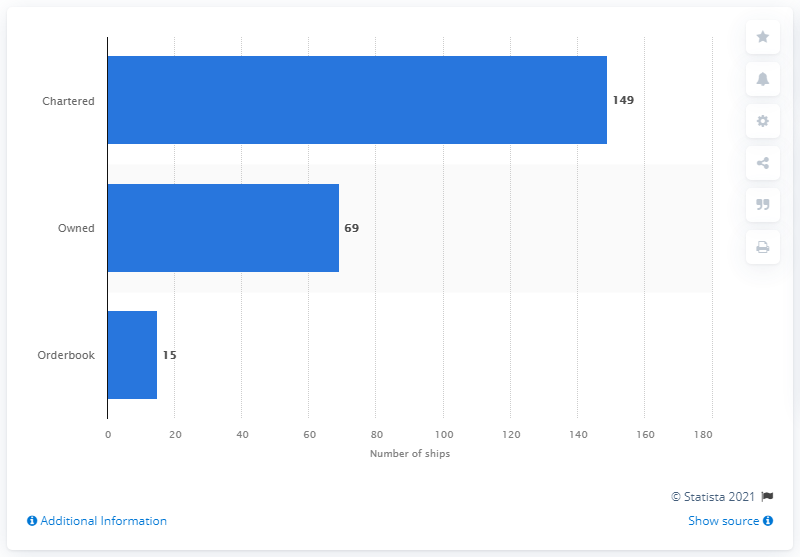Identify some key points in this picture. ONE (Ocean Network Express) owned 149 ships. 